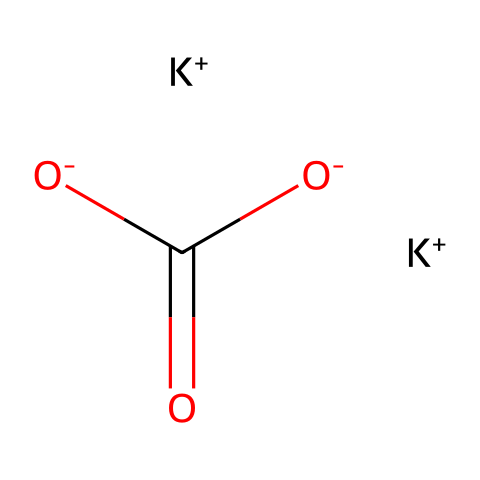what is the chemical name of this compound? The SMILES representation corresponds to potassium carbonate, which consists of potassium ions and carbonate ions.
Answer: potassium carbonate how many potassium ions are present in the structure? In the SMILES representation, there are two instances of [K+], indicating a total of two potassium ions.
Answer: 2 what kind of ions are represented in this structure? The structure contains potassium cations ([K+]) and carbonate anions ([O-]C(=O)[O-]), which are characteristic of a salt like potassium carbonate.
Answer: cations and anions what is the oxidation state of potassium in this compound? Potassium typically has a +1 oxidation state, as indicated by the [K+] notation in the SMILES, confirming its positive charge.
Answer: +1 how many oxygen atoms are present in this compound? In the carbonates, there are a total of three oxygen atoms connected to the carbonate group ([O-]C(=O)[O-]), thus totaling three.
Answer: 3 which part of the chemical indicates its alkaline nature? The presence of potassium ions ([K+]) along with the carbonate ion contributes to the alkaline properties, typical of bases.
Answer: potassium ions what is the charge of the carbonate ion in this structure? The charge on the carbonate ion can be derived from the two negative oxygen charges ([O-]C(=O)[O-]), indicating it has a -2 charge.
Answer: -2 